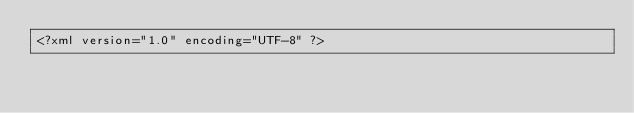Convert code to text. <code><loc_0><loc_0><loc_500><loc_500><_HTML_><?xml version="1.0" encoding="UTF-8" ?></code> 